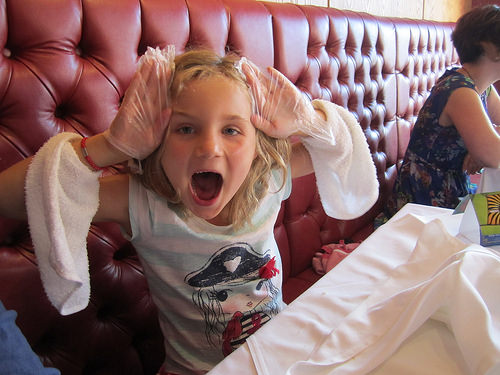<image>
Is the towel in front of the girl? No. The towel is not in front of the girl. The spatial positioning shows a different relationship between these objects. 